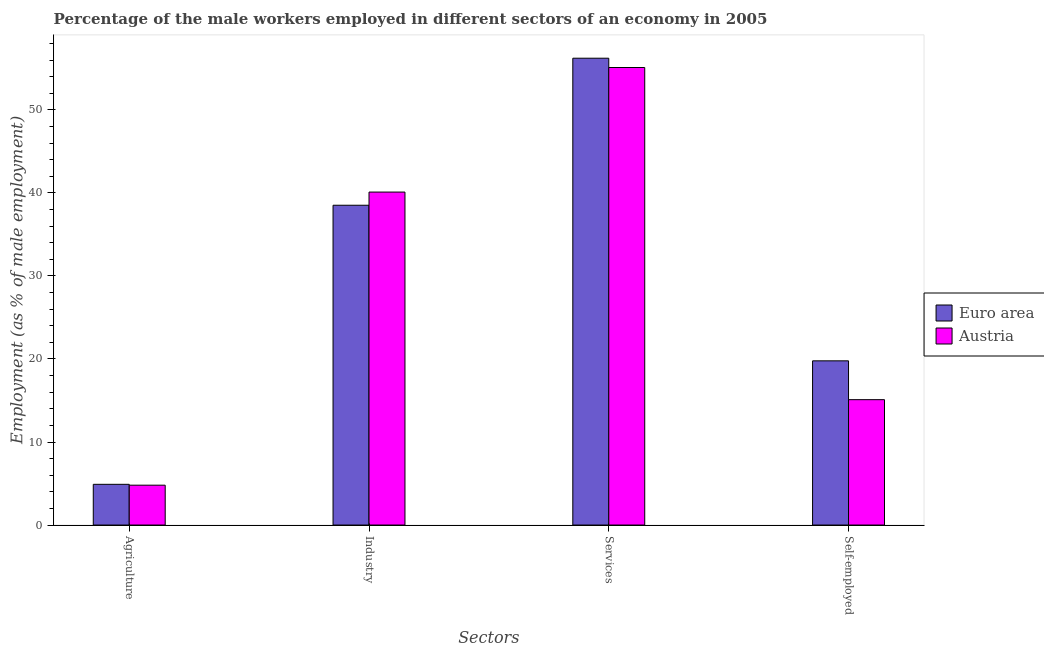How many different coloured bars are there?
Your answer should be compact. 2. How many bars are there on the 3rd tick from the left?
Give a very brief answer. 2. What is the label of the 1st group of bars from the left?
Your answer should be compact. Agriculture. What is the percentage of self employed male workers in Euro area?
Your response must be concise. 19.78. Across all countries, what is the maximum percentage of self employed male workers?
Provide a short and direct response. 19.78. Across all countries, what is the minimum percentage of male workers in agriculture?
Offer a very short reply. 4.8. What is the total percentage of male workers in industry in the graph?
Offer a terse response. 78.61. What is the difference between the percentage of male workers in agriculture in Austria and that in Euro area?
Offer a terse response. -0.1. What is the difference between the percentage of male workers in agriculture in Austria and the percentage of self employed male workers in Euro area?
Provide a short and direct response. -14.98. What is the average percentage of male workers in agriculture per country?
Give a very brief answer. 4.85. What is the difference between the percentage of male workers in agriculture and percentage of self employed male workers in Euro area?
Offer a very short reply. -14.87. In how many countries, is the percentage of male workers in industry greater than 20 %?
Give a very brief answer. 2. What is the ratio of the percentage of male workers in agriculture in Austria to that in Euro area?
Provide a succinct answer. 0.98. Is the percentage of male workers in services in Euro area less than that in Austria?
Your answer should be very brief. No. Is the difference between the percentage of male workers in agriculture in Austria and Euro area greater than the difference between the percentage of male workers in industry in Austria and Euro area?
Your answer should be compact. No. What is the difference between the highest and the second highest percentage of male workers in agriculture?
Your answer should be compact. 0.1. What is the difference between the highest and the lowest percentage of male workers in agriculture?
Your response must be concise. 0.1. Is the sum of the percentage of male workers in industry in Austria and Euro area greater than the maximum percentage of male workers in agriculture across all countries?
Offer a very short reply. Yes. What does the 2nd bar from the right in Services represents?
Keep it short and to the point. Euro area. Are all the bars in the graph horizontal?
Keep it short and to the point. No. Does the graph contain any zero values?
Your answer should be very brief. No. Does the graph contain grids?
Your answer should be compact. No. Where does the legend appear in the graph?
Your answer should be compact. Center right. How many legend labels are there?
Offer a very short reply. 2. How are the legend labels stacked?
Your answer should be compact. Vertical. What is the title of the graph?
Keep it short and to the point. Percentage of the male workers employed in different sectors of an economy in 2005. Does "Rwanda" appear as one of the legend labels in the graph?
Your response must be concise. No. What is the label or title of the X-axis?
Your response must be concise. Sectors. What is the label or title of the Y-axis?
Your answer should be very brief. Employment (as % of male employment). What is the Employment (as % of male employment) in Euro area in Agriculture?
Give a very brief answer. 4.9. What is the Employment (as % of male employment) of Austria in Agriculture?
Provide a succinct answer. 4.8. What is the Employment (as % of male employment) in Euro area in Industry?
Make the answer very short. 38.51. What is the Employment (as % of male employment) in Austria in Industry?
Provide a short and direct response. 40.1. What is the Employment (as % of male employment) of Euro area in Services?
Keep it short and to the point. 56.22. What is the Employment (as % of male employment) of Austria in Services?
Your answer should be compact. 55.1. What is the Employment (as % of male employment) of Euro area in Self-employed?
Keep it short and to the point. 19.78. What is the Employment (as % of male employment) in Austria in Self-employed?
Keep it short and to the point. 15.1. Across all Sectors, what is the maximum Employment (as % of male employment) of Euro area?
Ensure brevity in your answer.  56.22. Across all Sectors, what is the maximum Employment (as % of male employment) in Austria?
Your answer should be very brief. 55.1. Across all Sectors, what is the minimum Employment (as % of male employment) of Euro area?
Provide a short and direct response. 4.9. Across all Sectors, what is the minimum Employment (as % of male employment) of Austria?
Your response must be concise. 4.8. What is the total Employment (as % of male employment) in Euro area in the graph?
Ensure brevity in your answer.  119.41. What is the total Employment (as % of male employment) of Austria in the graph?
Ensure brevity in your answer.  115.1. What is the difference between the Employment (as % of male employment) in Euro area in Agriculture and that in Industry?
Offer a very short reply. -33.61. What is the difference between the Employment (as % of male employment) in Austria in Agriculture and that in Industry?
Your answer should be very brief. -35.3. What is the difference between the Employment (as % of male employment) of Euro area in Agriculture and that in Services?
Your answer should be compact. -51.31. What is the difference between the Employment (as % of male employment) in Austria in Agriculture and that in Services?
Provide a succinct answer. -50.3. What is the difference between the Employment (as % of male employment) of Euro area in Agriculture and that in Self-employed?
Your answer should be very brief. -14.87. What is the difference between the Employment (as % of male employment) in Euro area in Industry and that in Services?
Keep it short and to the point. -17.71. What is the difference between the Employment (as % of male employment) in Euro area in Industry and that in Self-employed?
Offer a terse response. 18.74. What is the difference between the Employment (as % of male employment) of Austria in Industry and that in Self-employed?
Provide a succinct answer. 25. What is the difference between the Employment (as % of male employment) of Euro area in Services and that in Self-employed?
Provide a succinct answer. 36.44. What is the difference between the Employment (as % of male employment) of Austria in Services and that in Self-employed?
Your response must be concise. 40. What is the difference between the Employment (as % of male employment) in Euro area in Agriculture and the Employment (as % of male employment) in Austria in Industry?
Offer a very short reply. -35.2. What is the difference between the Employment (as % of male employment) of Euro area in Agriculture and the Employment (as % of male employment) of Austria in Services?
Your answer should be very brief. -50.2. What is the difference between the Employment (as % of male employment) in Euro area in Agriculture and the Employment (as % of male employment) in Austria in Self-employed?
Provide a succinct answer. -10.2. What is the difference between the Employment (as % of male employment) of Euro area in Industry and the Employment (as % of male employment) of Austria in Services?
Offer a very short reply. -16.59. What is the difference between the Employment (as % of male employment) in Euro area in Industry and the Employment (as % of male employment) in Austria in Self-employed?
Your answer should be compact. 23.41. What is the difference between the Employment (as % of male employment) of Euro area in Services and the Employment (as % of male employment) of Austria in Self-employed?
Make the answer very short. 41.12. What is the average Employment (as % of male employment) of Euro area per Sectors?
Offer a terse response. 29.85. What is the average Employment (as % of male employment) of Austria per Sectors?
Make the answer very short. 28.77. What is the difference between the Employment (as % of male employment) in Euro area and Employment (as % of male employment) in Austria in Agriculture?
Keep it short and to the point. 0.1. What is the difference between the Employment (as % of male employment) of Euro area and Employment (as % of male employment) of Austria in Industry?
Provide a succinct answer. -1.59. What is the difference between the Employment (as % of male employment) in Euro area and Employment (as % of male employment) in Austria in Services?
Offer a terse response. 1.12. What is the difference between the Employment (as % of male employment) in Euro area and Employment (as % of male employment) in Austria in Self-employed?
Your answer should be very brief. 4.68. What is the ratio of the Employment (as % of male employment) of Euro area in Agriculture to that in Industry?
Your response must be concise. 0.13. What is the ratio of the Employment (as % of male employment) in Austria in Agriculture to that in Industry?
Your answer should be very brief. 0.12. What is the ratio of the Employment (as % of male employment) of Euro area in Agriculture to that in Services?
Give a very brief answer. 0.09. What is the ratio of the Employment (as % of male employment) of Austria in Agriculture to that in Services?
Your answer should be compact. 0.09. What is the ratio of the Employment (as % of male employment) of Euro area in Agriculture to that in Self-employed?
Offer a terse response. 0.25. What is the ratio of the Employment (as % of male employment) in Austria in Agriculture to that in Self-employed?
Your response must be concise. 0.32. What is the ratio of the Employment (as % of male employment) of Euro area in Industry to that in Services?
Ensure brevity in your answer.  0.69. What is the ratio of the Employment (as % of male employment) in Austria in Industry to that in Services?
Keep it short and to the point. 0.73. What is the ratio of the Employment (as % of male employment) of Euro area in Industry to that in Self-employed?
Provide a short and direct response. 1.95. What is the ratio of the Employment (as % of male employment) of Austria in Industry to that in Self-employed?
Your answer should be compact. 2.66. What is the ratio of the Employment (as % of male employment) of Euro area in Services to that in Self-employed?
Offer a very short reply. 2.84. What is the ratio of the Employment (as % of male employment) of Austria in Services to that in Self-employed?
Make the answer very short. 3.65. What is the difference between the highest and the second highest Employment (as % of male employment) of Euro area?
Your answer should be very brief. 17.71. What is the difference between the highest and the second highest Employment (as % of male employment) in Austria?
Give a very brief answer. 15. What is the difference between the highest and the lowest Employment (as % of male employment) of Euro area?
Give a very brief answer. 51.31. What is the difference between the highest and the lowest Employment (as % of male employment) in Austria?
Your response must be concise. 50.3. 